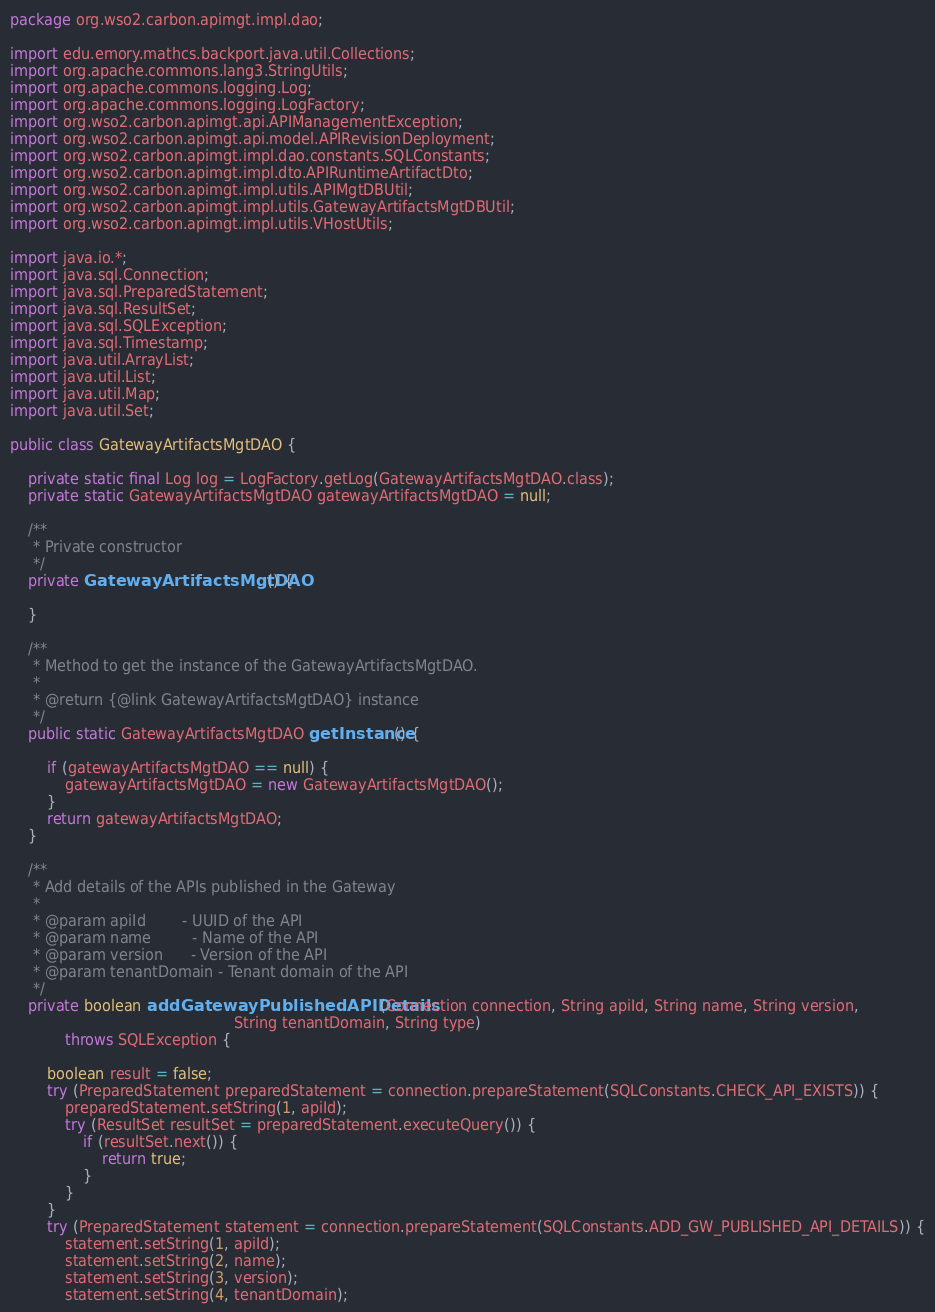Convert code to text. <code><loc_0><loc_0><loc_500><loc_500><_Java_>package org.wso2.carbon.apimgt.impl.dao;

import edu.emory.mathcs.backport.java.util.Collections;
import org.apache.commons.lang3.StringUtils;
import org.apache.commons.logging.Log;
import org.apache.commons.logging.LogFactory;
import org.wso2.carbon.apimgt.api.APIManagementException;
import org.wso2.carbon.apimgt.api.model.APIRevisionDeployment;
import org.wso2.carbon.apimgt.impl.dao.constants.SQLConstants;
import org.wso2.carbon.apimgt.impl.dto.APIRuntimeArtifactDto;
import org.wso2.carbon.apimgt.impl.utils.APIMgtDBUtil;
import org.wso2.carbon.apimgt.impl.utils.GatewayArtifactsMgtDBUtil;
import org.wso2.carbon.apimgt.impl.utils.VHostUtils;

import java.io.*;
import java.sql.Connection;
import java.sql.PreparedStatement;
import java.sql.ResultSet;
import java.sql.SQLException;
import java.sql.Timestamp;
import java.util.ArrayList;
import java.util.List;
import java.util.Map;
import java.util.Set;

public class GatewayArtifactsMgtDAO {

    private static final Log log = LogFactory.getLog(GatewayArtifactsMgtDAO.class);
    private static GatewayArtifactsMgtDAO gatewayArtifactsMgtDAO = null;

    /**
     * Private constructor
     */
    private GatewayArtifactsMgtDAO() {

    }

    /**
     * Method to get the instance of the GatewayArtifactsMgtDAO.
     *
     * @return {@link GatewayArtifactsMgtDAO} instance
     */
    public static GatewayArtifactsMgtDAO getInstance() {

        if (gatewayArtifactsMgtDAO == null) {
            gatewayArtifactsMgtDAO = new GatewayArtifactsMgtDAO();
        }
        return gatewayArtifactsMgtDAO;
    }

    /**
     * Add details of the APIs published in the Gateway
     *
     * @param apiId        - UUID of the API
     * @param name         - Name of the API
     * @param version      - Version of the API
     * @param tenantDomain - Tenant domain of the API
     */
    private boolean addGatewayPublishedAPIDetails(Connection connection, String apiId, String name, String version,
                                                 String tenantDomain, String type)
            throws SQLException {

        boolean result = false;
        try (PreparedStatement preparedStatement = connection.prepareStatement(SQLConstants.CHECK_API_EXISTS)) {
            preparedStatement.setString(1, apiId);
            try (ResultSet resultSet = preparedStatement.executeQuery()) {
                if (resultSet.next()) {
                    return true;
                }
            }
        }
        try (PreparedStatement statement = connection.prepareStatement(SQLConstants.ADD_GW_PUBLISHED_API_DETAILS)) {
            statement.setString(1, apiId);
            statement.setString(2, name);
            statement.setString(3, version);
            statement.setString(4, tenantDomain);</code> 